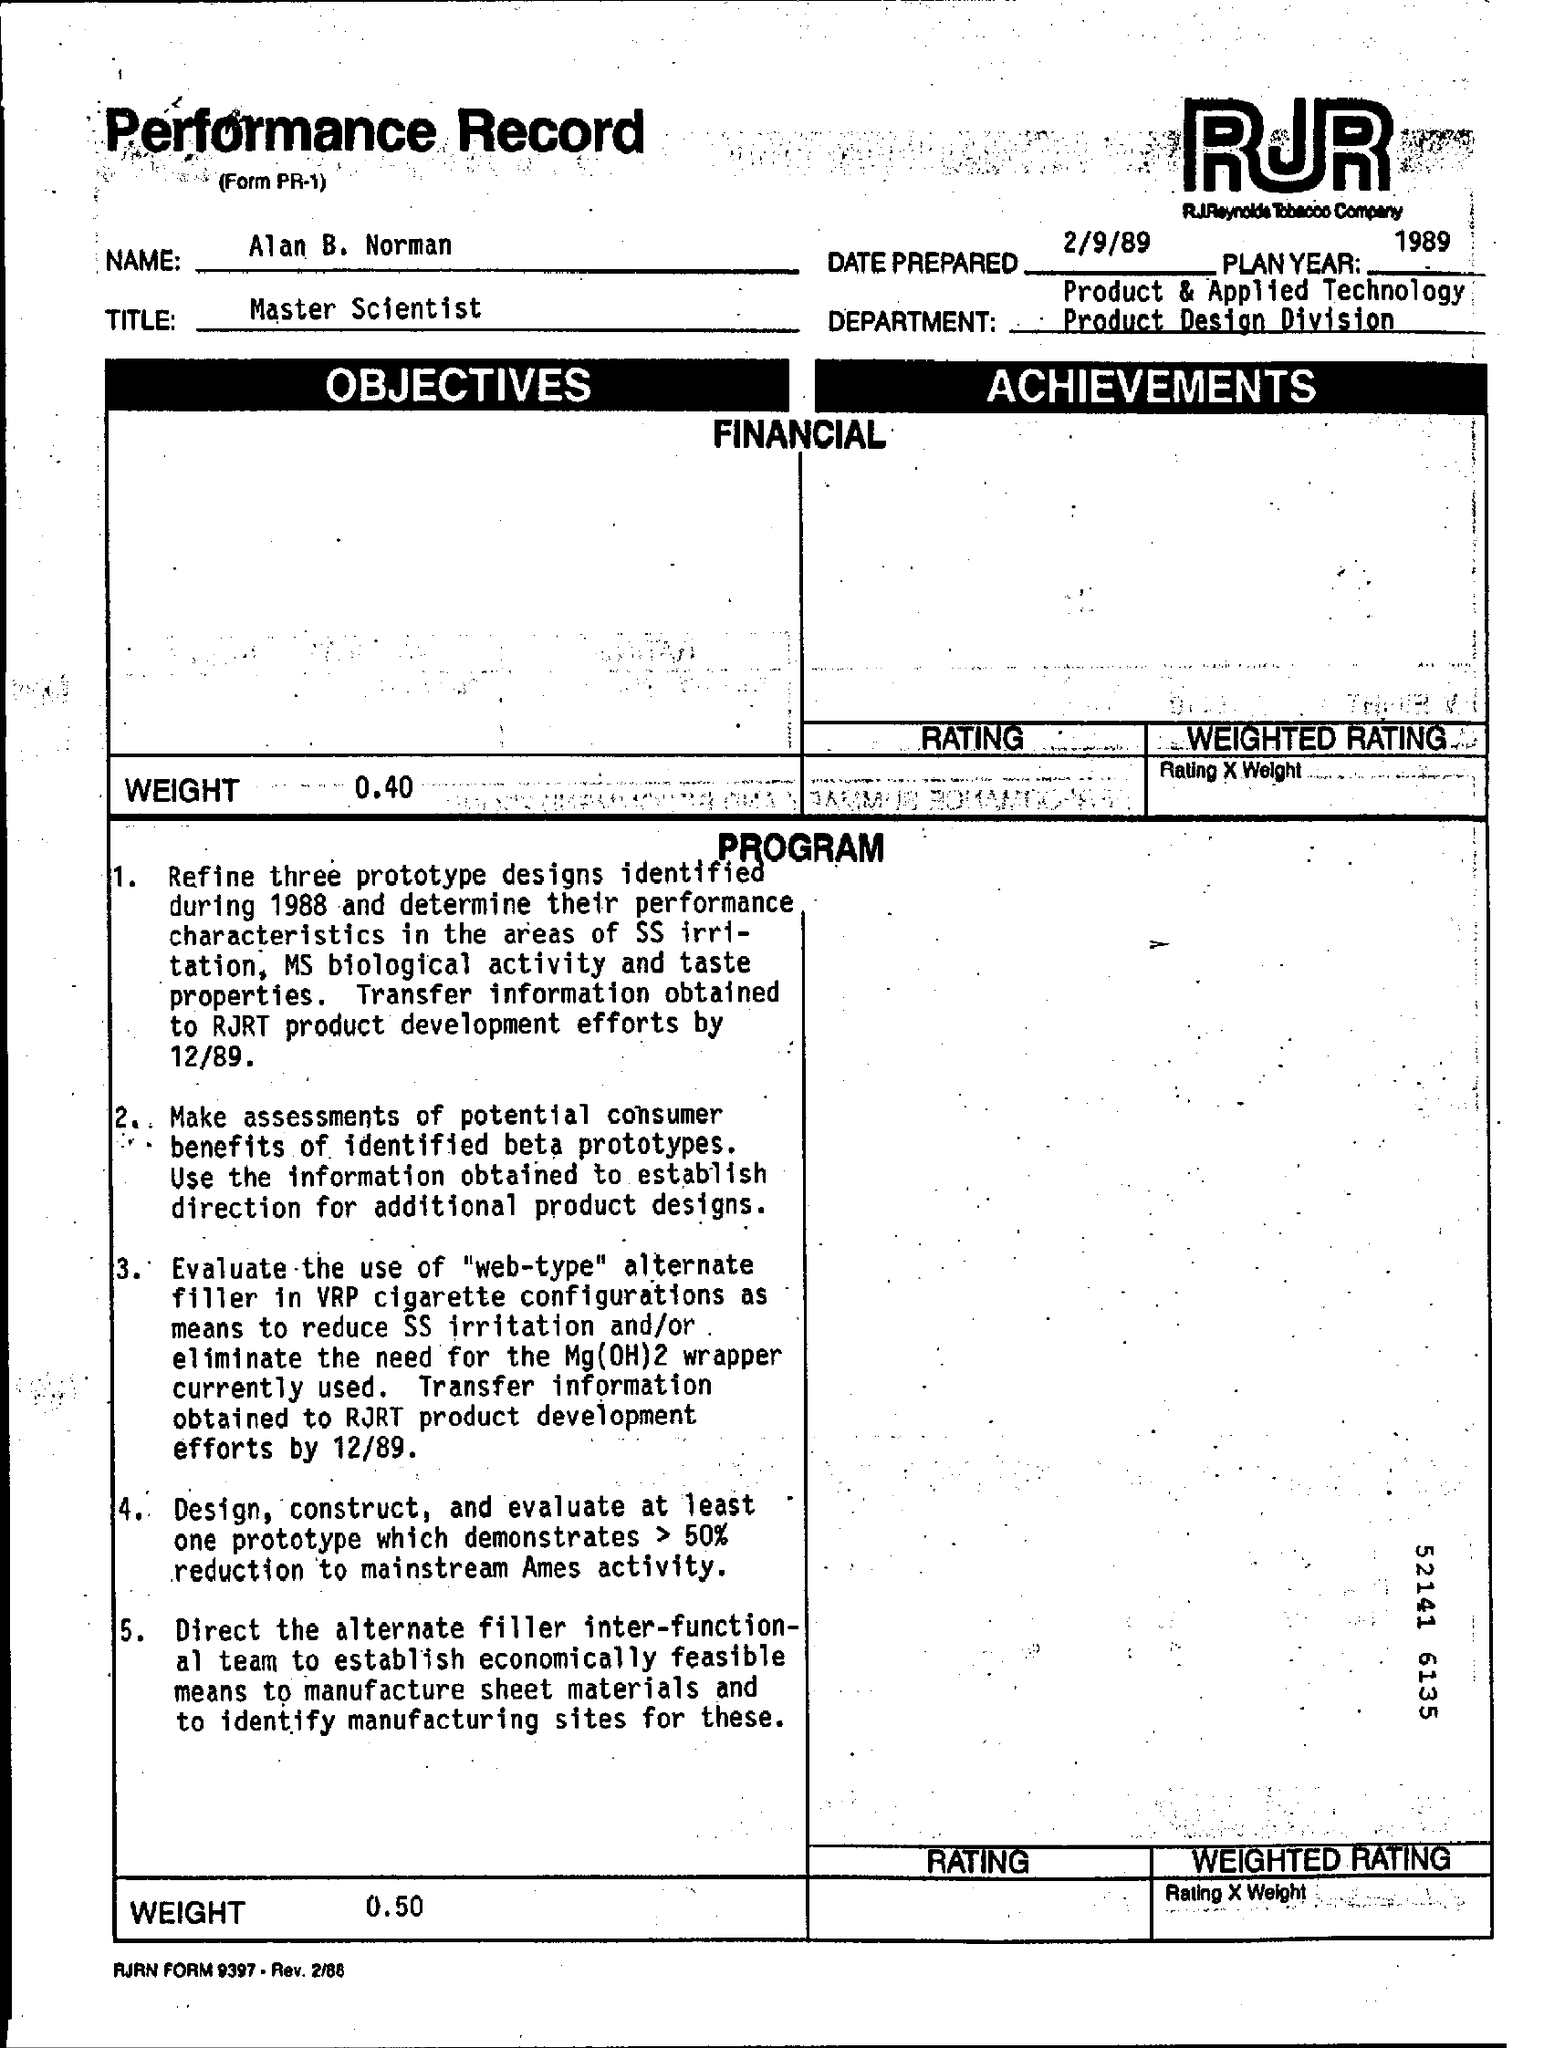What is the title ?
Offer a very short reply. Master Scientist. What is the name mentioned ?
Keep it short and to the point. Alan B. Norman. What is the plan  year
Your response must be concise. 1989. What is date prepared ?
Provide a short and direct response. 2/9/89. What is the weight mentioned in the objectives ?
Provide a succinct answer. 0.40. What is the weight mentioned in the program ?
Provide a short and direct response. 0.50. 